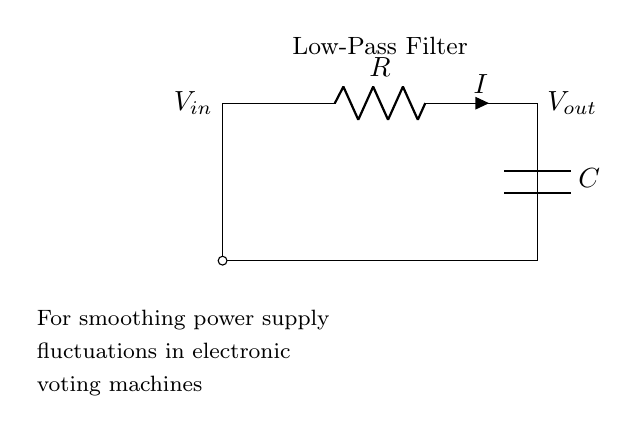What are the components in the circuit? The circuit includes a resistor labeled R and a capacitor labeled C. These components are essential for creating the low-pass filter function.
Answer: resistor and capacitor What type of filter is shown in the diagram? The circuit is a low-pass filter, which allows low-frequency signals to pass through while attenuating high-frequency signals. This is indicated by the title in the diagram.
Answer: Low-Pass Filter What is the purpose of this circuit? The purpose of the circuit is to smooth power supply fluctuations in electronic voting machines. This is mentioned in the description beneath the circuit diagram, indicating its specific application.
Answer: Smoothing power supply fluctuations What is the current direction in the circuit? The current flows from the input voltage source through the resistor first and then to the capacitor. This is determined by the orientation of the connections indicated in the diagram.
Answer: From input to capacitor How does the capacitor affect the circuit operation? The capacitor stores charge and releases it slowly, thus filtering out rapid fluctuations in voltage. This is a key function of capacitors in low-pass filters, as they allow steady signals while blocking rapid changes.
Answer: It smooths voltage fluctuations What is the relationship between the resistor and capacitor in this filter? The resistor and capacitor form an RC time constant that defines the cutoff frequency of the filter. Their values affect how quickly the circuit responds to changes, determining the filter's effectiveness.
Answer: They determine the cutoff frequency What does Vout represent in this circuit? Vout represents the output voltage across the capacitor, which is the smoothed voltage that is less responsive to rapid changes due to the capacitive filtering effect.
Answer: The smoothed output voltage 